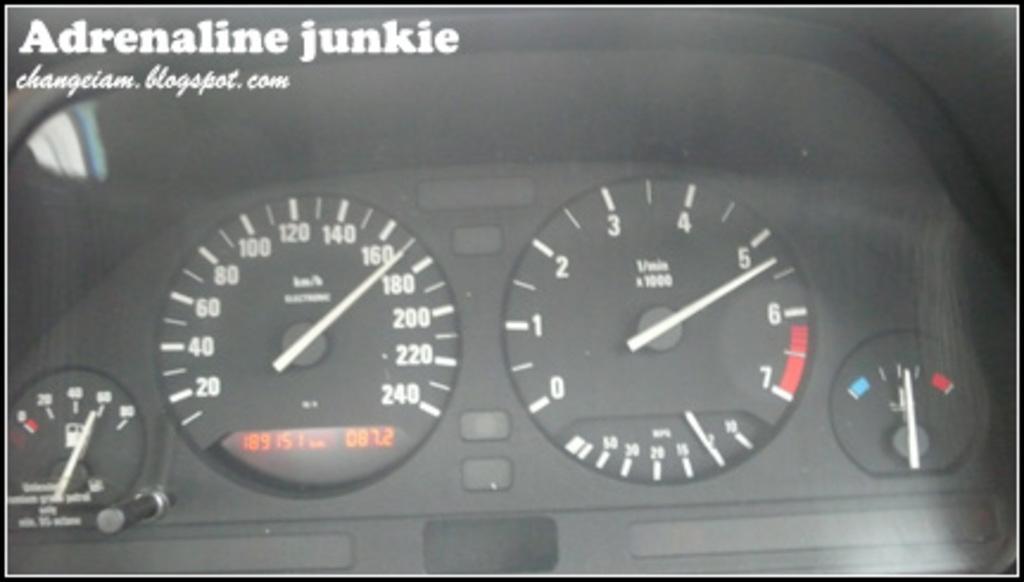How would you summarize this image in a sentence or two? As we can see in the image there is a speedometer. 